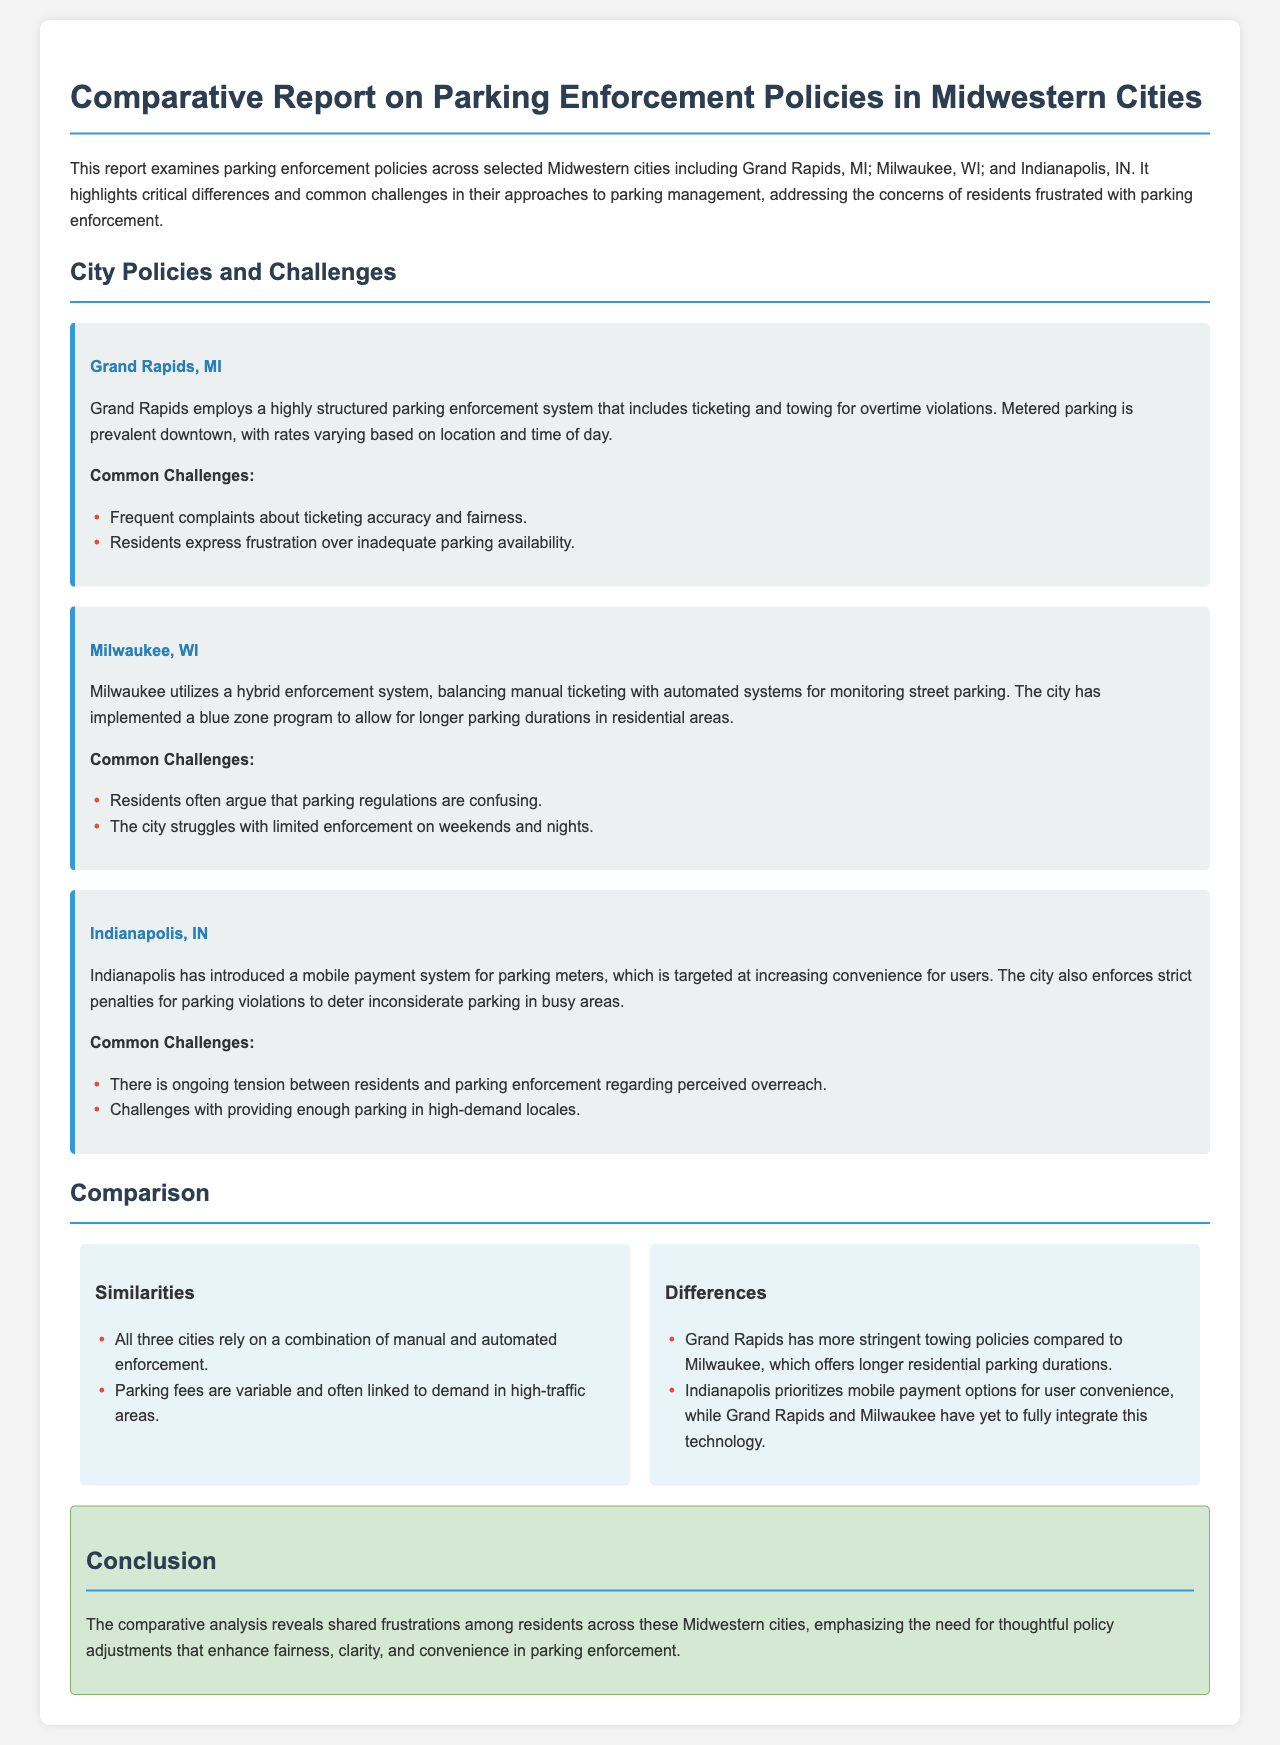What city is compared to Grand Rapids in the report? The report compares Grand Rapids to Milwaukee and Indianapolis, making these cities the focus of the analysis.
Answer: Milwaukee, Indianapolis What is a common challenge mentioned for Grand Rapids? A specific challenge listed for Grand Rapids is frequent complaints about ticketing accuracy and fairness.
Answer: Ticketing accuracy and fairness What parking system does Indianapolis use to enhance convenience? Indianapolis has introduced a mobile payment system for parking meters aimed at increasing convenience for users.
Answer: Mobile payment system How do the parking fees in the cities vary? The parking fees in all three cities are variable and often linked to demand in high-traffic areas, indicating a common approach to pricing based on location and time.
Answer: Linked to demand What distinguishes Grand Rapids' towing policies from Milwaukee's? Grand Rapids has more stringent towing policies compared to Milwaukee, which allows for longer parking durations in residential areas.
Answer: More stringent towing policies What is a shared frustration noted across these Midwestern cities? The conclusion mentions shared frustrations among residents regarding fairness, clarity, and convenience in parking enforcement.
Answer: Fairness, clarity, convenience What type of parking enforcement system does Milwaukee balance? Milwaukee utilizes a hybrid enforcement system that combines manual ticketing with automated systems for monitoring street parking.
Answer: Hybrid enforcement system What feature does the report identify that differentiates Indianapolis from the other two cities? Indianapolis prioritizes mobile payment options for user convenience, which is a distinguishing feature compared to Grand Rapids and Milwaukee.
Answer: Mobile payment options 